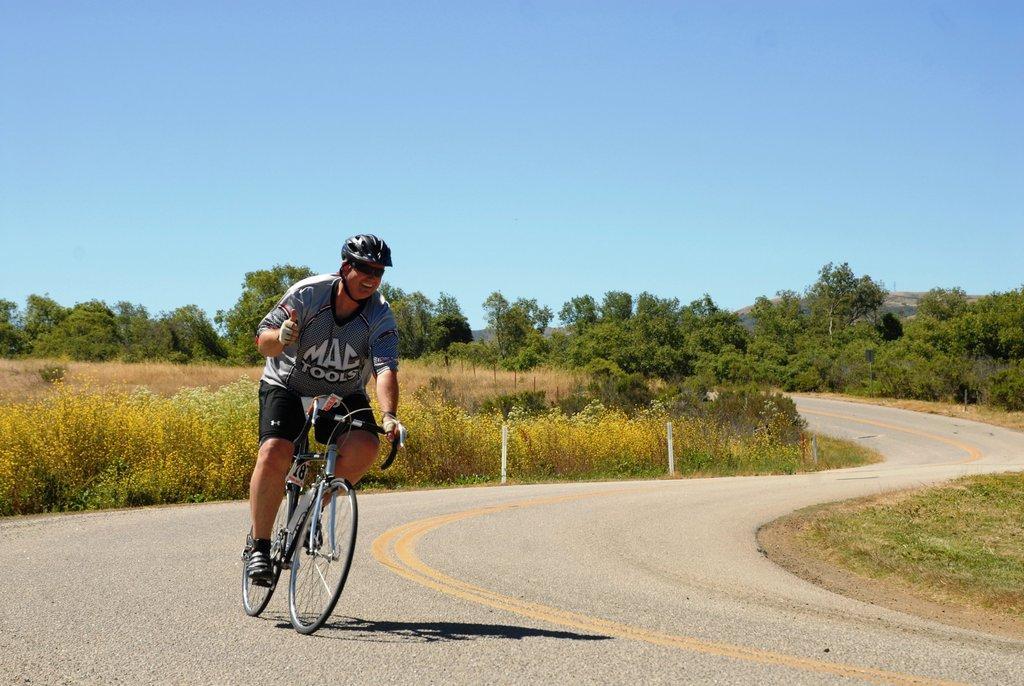Please provide a concise description of this image. In this image we can see a man wearing a helmet and riding a bicycle on the road and we can see some plants and grass on the ground and there are some trees in the background and at the top we can see the sky. 